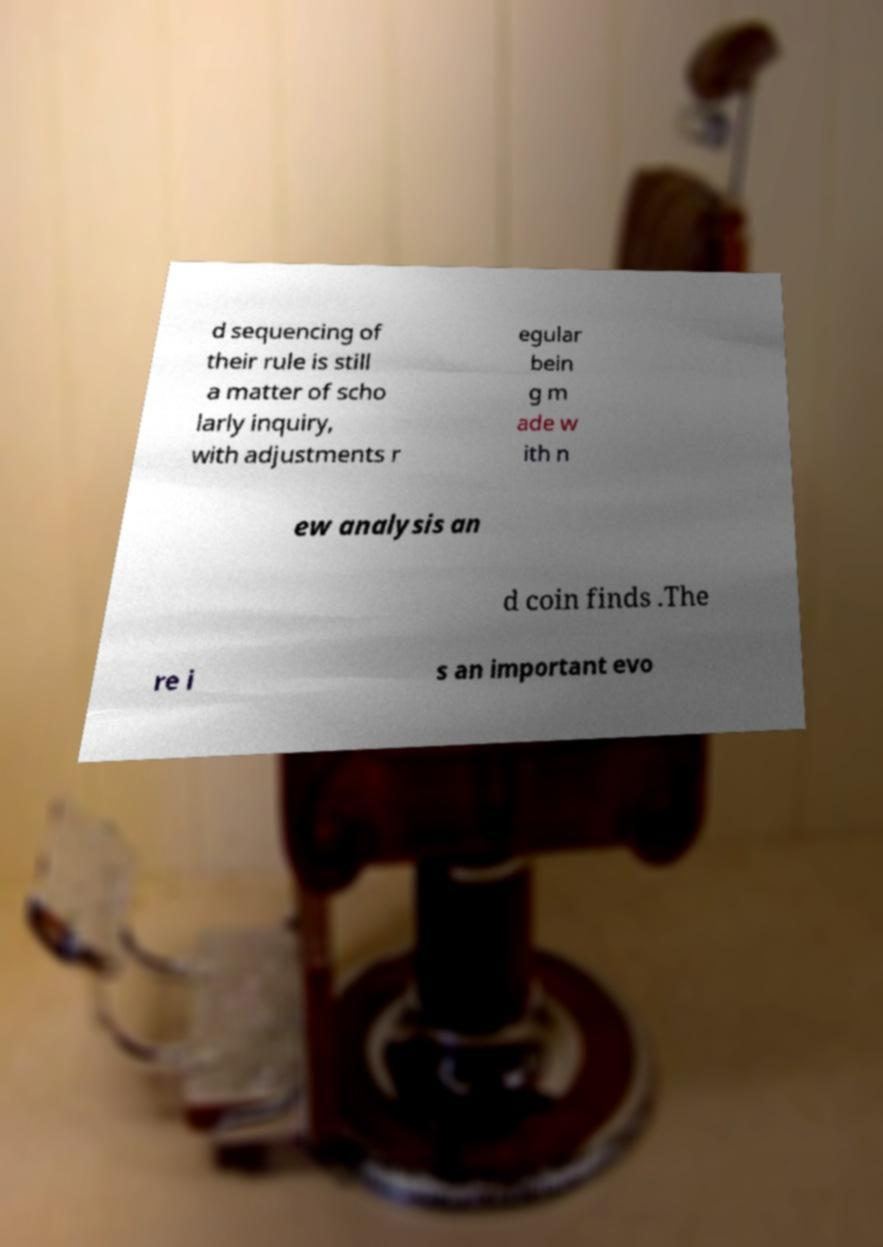Please identify and transcribe the text found in this image. d sequencing of their rule is still a matter of scho larly inquiry, with adjustments r egular bein g m ade w ith n ew analysis an d coin finds .The re i s an important evo 